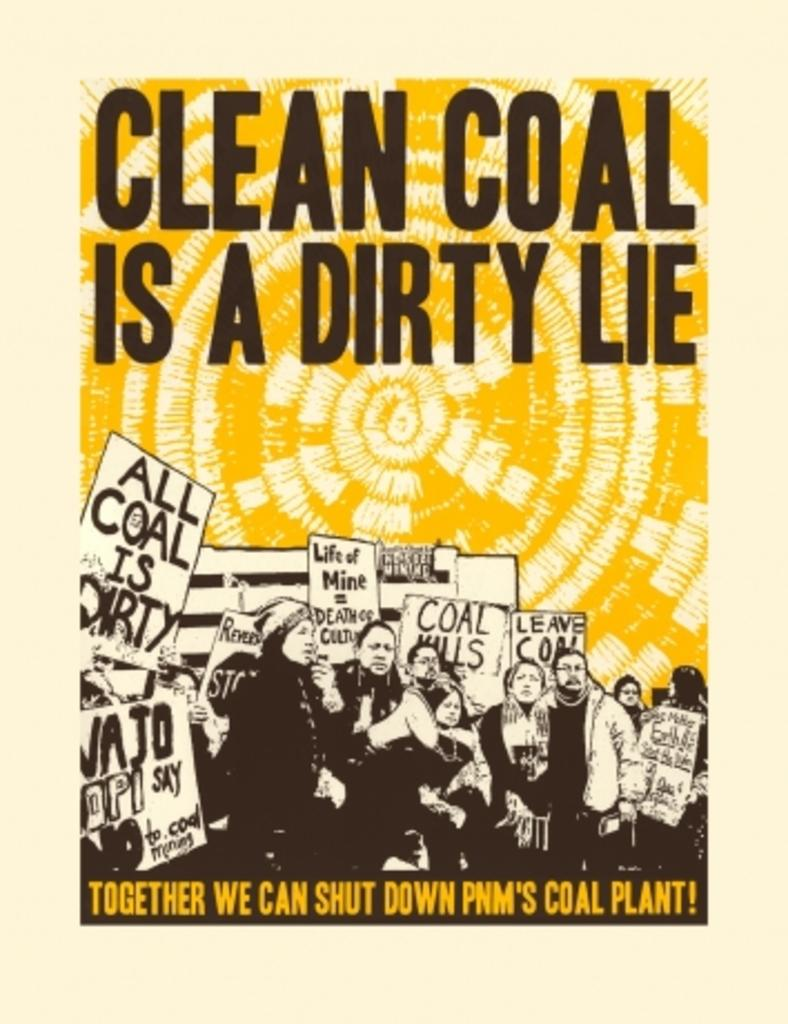<image>
Render a clear and concise summary of the photo. a poster with the slogan 'clean coal is a dirty lie' 